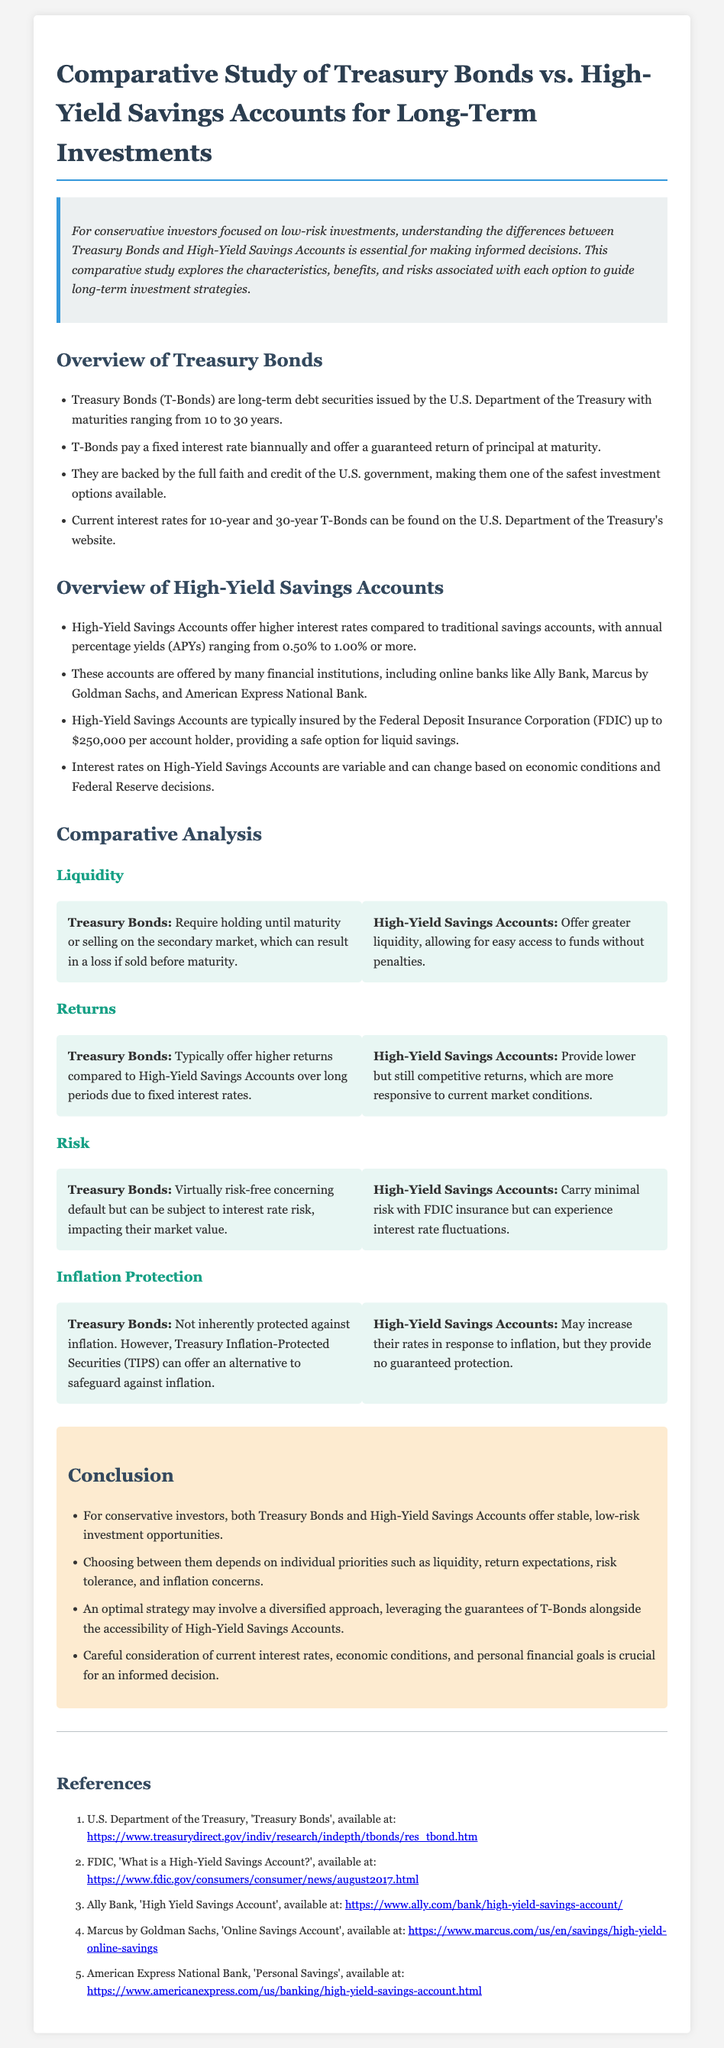What are Treasury Bonds? Treasury Bonds (T-Bonds) are long-term debt securities issued by the U.S. Department of the Treasury with maturities ranging from 10 to 30 years.
Answer: Long-term debt securities What is the typical interest rate range for High-Yield Savings Accounts? High-Yield Savings Accounts offer higher interest rates compared to traditional savings accounts, with annual percentage yields (APYs) ranging from 0.50% to 1.00% or more.
Answer: 0.50% to 1.00% How often do Treasury Bonds pay interest? T-Bonds pay a fixed interest rate biannually and offer a guaranteed return of principal at maturity.
Answer: Biannually What provides insurance for High-Yield Savings Accounts? High-Yield Savings Accounts are typically insured by the Federal Deposit Insurance Corporation (FDIC) up to $250,000 per account holder.
Answer: FDIC What is the liquidity status of Treasury Bonds? Treasury Bonds require holding until maturity or selling on the secondary market, which can result in a loss if sold before maturity.
Answer: Requires holding until maturity What is a key risk associated with Treasury Bonds? Treasury Bonds are virtually risk-free concerning default but can be subject to interest rate risk, impacting their market value.
Answer: Interest rate risk What is the conclusion about investment strategies? An optimal strategy may involve a diversified approach, leveraging the guarantees of T-Bonds alongside the accessibility of High-Yield Savings Accounts.
Answer: Diversified approach What is the minimum expected return for High-Yield Savings Accounts? While variable, competitive returns are offered by High-Yield Savings Accounts, but specific minimums are not detailed in the document.
Answer: Competitive returns What is a characteristic of Treasury Inflation-Protected Securities (TIPS)? TIPS can offer an alternative to safeguard against inflation which is a concern not covered inherently by regular Treasury Bonds.
Answer: Inflation protection 